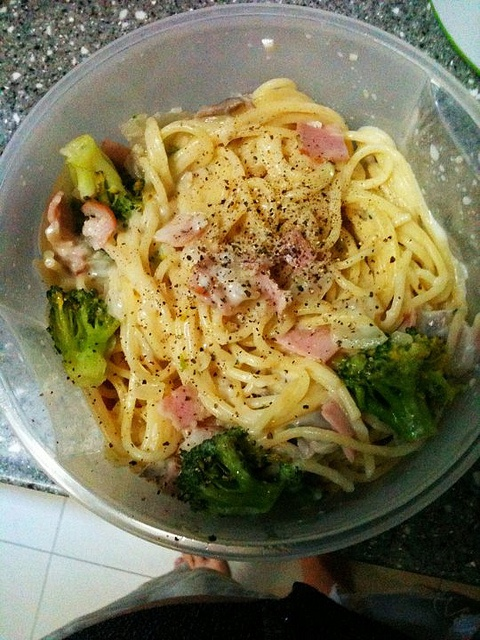Describe the objects in this image and their specific colors. I can see bowl in black, darkgray, and tan tones, people in black, gray, and maroon tones, broccoli in black and darkgreen tones, broccoli in black, darkgreen, and olive tones, and broccoli in black and olive tones in this image. 